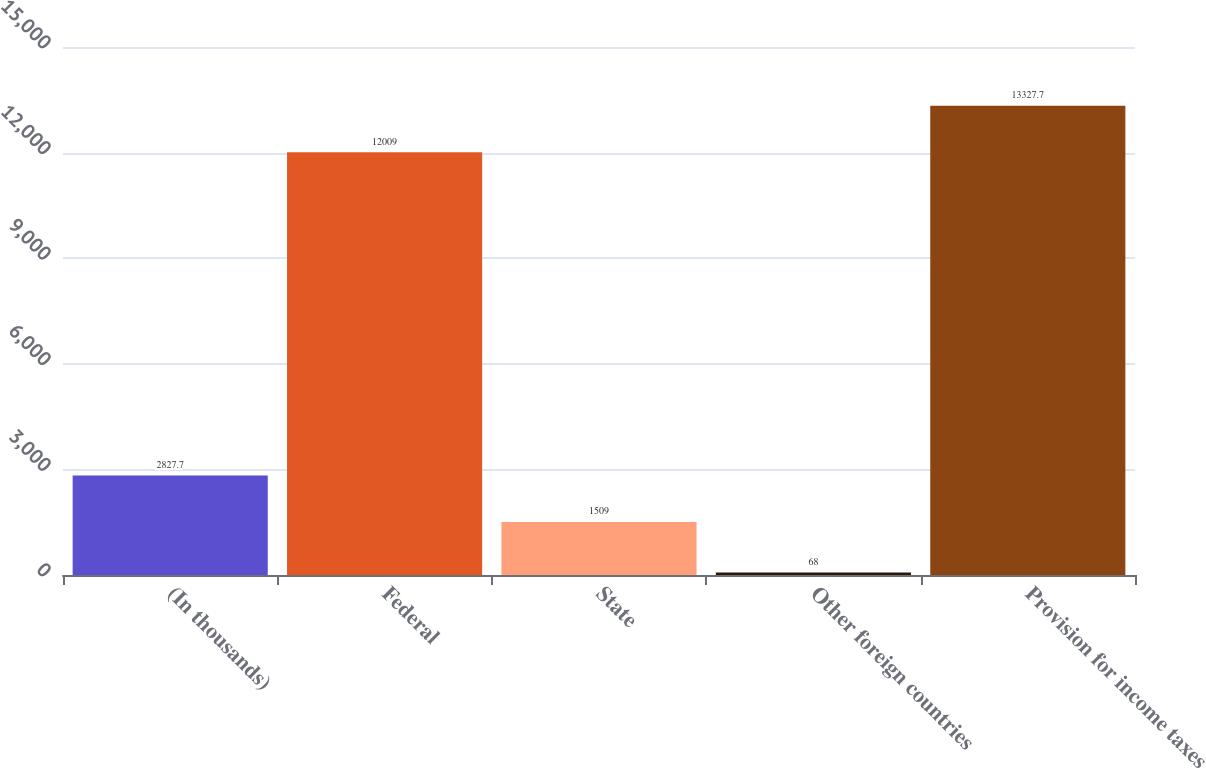Convert chart. <chart><loc_0><loc_0><loc_500><loc_500><bar_chart><fcel>(In thousands)<fcel>Federal<fcel>State<fcel>Other foreign countries<fcel>Provision for income taxes<nl><fcel>2827.7<fcel>12009<fcel>1509<fcel>68<fcel>13327.7<nl></chart> 